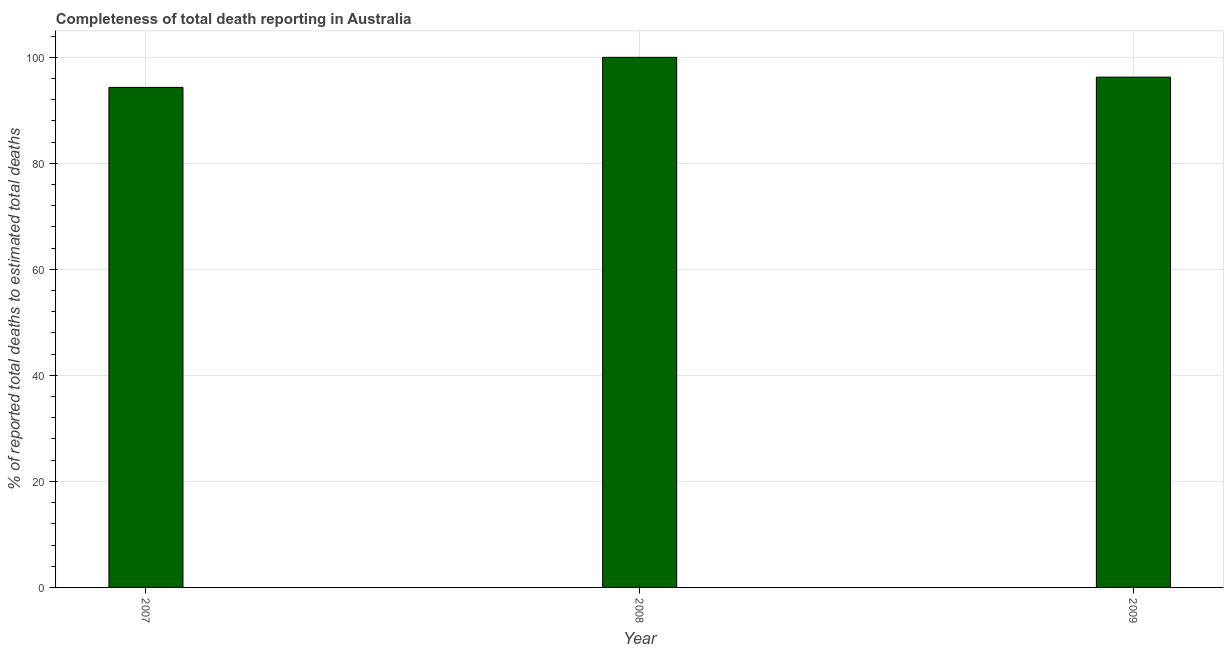Does the graph contain any zero values?
Give a very brief answer. No. Does the graph contain grids?
Ensure brevity in your answer.  Yes. What is the title of the graph?
Offer a terse response. Completeness of total death reporting in Australia. What is the label or title of the Y-axis?
Offer a very short reply. % of reported total deaths to estimated total deaths. What is the completeness of total death reports in 2007?
Your answer should be compact. 94.32. Across all years, what is the maximum completeness of total death reports?
Keep it short and to the point. 100. Across all years, what is the minimum completeness of total death reports?
Ensure brevity in your answer.  94.32. In which year was the completeness of total death reports maximum?
Offer a terse response. 2008. What is the sum of the completeness of total death reports?
Give a very brief answer. 290.59. What is the difference between the completeness of total death reports in 2008 and 2009?
Your answer should be very brief. 3.73. What is the average completeness of total death reports per year?
Provide a succinct answer. 96.86. What is the median completeness of total death reports?
Offer a very short reply. 96.27. In how many years, is the completeness of total death reports greater than 40 %?
Provide a succinct answer. 3. Do a majority of the years between 2008 and 2007 (inclusive) have completeness of total death reports greater than 24 %?
Provide a short and direct response. No. What is the ratio of the completeness of total death reports in 2008 to that in 2009?
Make the answer very short. 1.04. Is the difference between the completeness of total death reports in 2007 and 2008 greater than the difference between any two years?
Ensure brevity in your answer.  Yes. What is the difference between the highest and the second highest completeness of total death reports?
Ensure brevity in your answer.  3.73. What is the difference between the highest and the lowest completeness of total death reports?
Offer a very short reply. 5.68. In how many years, is the completeness of total death reports greater than the average completeness of total death reports taken over all years?
Your response must be concise. 1. How many years are there in the graph?
Offer a terse response. 3. Are the values on the major ticks of Y-axis written in scientific E-notation?
Keep it short and to the point. No. What is the % of reported total deaths to estimated total deaths of 2007?
Your answer should be very brief. 94.32. What is the % of reported total deaths to estimated total deaths in 2008?
Your answer should be very brief. 100. What is the % of reported total deaths to estimated total deaths in 2009?
Provide a succinct answer. 96.27. What is the difference between the % of reported total deaths to estimated total deaths in 2007 and 2008?
Give a very brief answer. -5.68. What is the difference between the % of reported total deaths to estimated total deaths in 2007 and 2009?
Make the answer very short. -1.94. What is the difference between the % of reported total deaths to estimated total deaths in 2008 and 2009?
Provide a succinct answer. 3.73. What is the ratio of the % of reported total deaths to estimated total deaths in 2007 to that in 2008?
Your response must be concise. 0.94. What is the ratio of the % of reported total deaths to estimated total deaths in 2008 to that in 2009?
Offer a terse response. 1.04. 